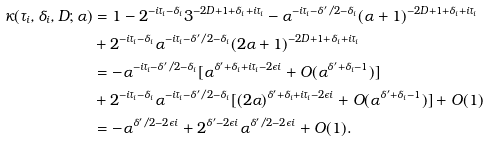<formula> <loc_0><loc_0><loc_500><loc_500>\kappa ( \tau _ { i } , \delta _ { i } , D ; \alpha ) & = 1 - 2 ^ { - i \tau _ { i } - \delta _ { i } } 3 ^ { - 2 D + 1 + \delta _ { i } + i \tau _ { i } } - \alpha ^ { - i \tau _ { i } - \delta ^ { \prime } / 2 - \delta _ { i } } ( \alpha + 1 ) ^ { - 2 D + 1 + \delta _ { i } + i \tau _ { i } } \\ & + 2 ^ { - i \tau _ { i } - \delta _ { i } } \alpha ^ { - i \tau _ { i } - \delta ^ { \prime } / 2 - \delta _ { i } } ( 2 \alpha + 1 ) ^ { - 2 D + 1 + \delta _ { i } + i \tau _ { i } } \\ & = - \alpha ^ { - i \tau _ { i } - \delta ^ { \prime } / 2 - \delta _ { i } } [ \alpha ^ { \delta ^ { \prime } + \delta _ { i } + i \tau _ { i } - 2 \epsilon i } + O ( \alpha ^ { \delta ^ { \prime } + \delta _ { i } - 1 } ) ] \\ & + 2 ^ { - i \tau _ { i } - \delta _ { i } } \alpha ^ { - i \tau _ { i } - \delta ^ { \prime } / 2 - \delta _ { i } } [ ( 2 \alpha ) ^ { \delta ^ { \prime } + \delta _ { i } + i \tau _ { i } - 2 \epsilon i } + O ( \alpha ^ { \delta ^ { \prime } + \delta _ { i } - 1 } ) ] + O ( 1 ) \\ & = - \alpha ^ { \delta ^ { \prime } / 2 - 2 \epsilon i } + 2 ^ { \delta ^ { \prime } - 2 \epsilon i } \alpha ^ { \delta ^ { \prime } / 2 - 2 \epsilon i } + O ( 1 ) .</formula> 